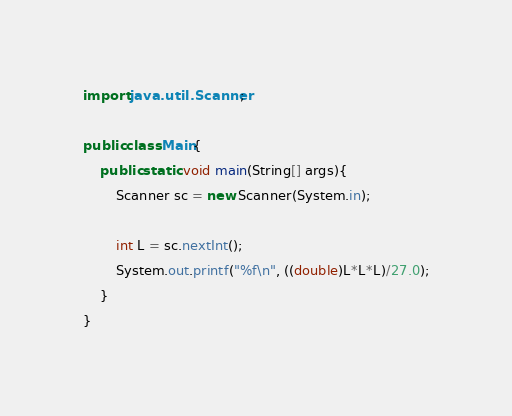Convert code to text. <code><loc_0><loc_0><loc_500><loc_500><_Java_>import java.util.Scanner;

public class Main{
    public static void main(String[] args){
        Scanner sc = new Scanner(System.in);

        int L = sc.nextInt();
        System.out.printf("%f\n", ((double)L*L*L)/27.0);
    }
}</code> 